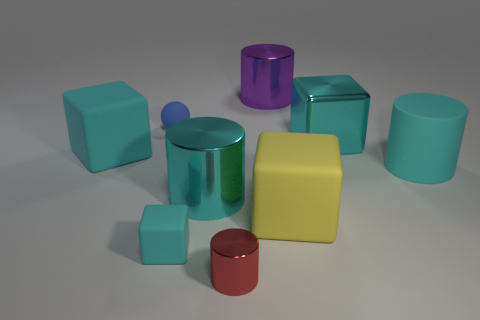There is a small cube; is its color the same as the large cylinder that is on the left side of the purple object?
Make the answer very short. Yes. What shape is the large thing that is on the left side of the small ball?
Your answer should be very brief. Cube. What number of other things are the same material as the blue sphere?
Keep it short and to the point. 4. What material is the red object?
Give a very brief answer. Metal. How many small objects are either gray metal things or yellow blocks?
Your answer should be very brief. 0. How many tiny blue spheres are left of the big purple cylinder?
Ensure brevity in your answer.  1. Are there any big shiny things of the same color as the small block?
Give a very brief answer. Yes. What is the shape of the purple metallic object that is the same size as the matte cylinder?
Your response must be concise. Cylinder. How many blue objects are small spheres or small metallic things?
Ensure brevity in your answer.  1. How many metallic blocks have the same size as the purple metallic cylinder?
Your answer should be compact. 1. 